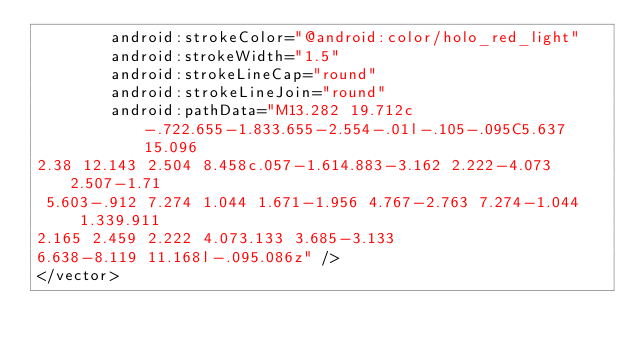Convert code to text. <code><loc_0><loc_0><loc_500><loc_500><_XML_>        android:strokeColor="@android:color/holo_red_light"
        android:strokeWidth="1.5"
        android:strokeLineCap="round"
        android:strokeLineJoin="round"
        android:pathData="M13.282 19.712c-.722.655-1.833.655-2.554-.01l-.105-.095C5.637 15.096
2.38 12.143 2.504 8.458c.057-1.614.883-3.162 2.222-4.073 2.507-1.71
 5.603-.912 7.274 1.044 1.671-1.956 4.767-2.763 7.274-1.044 1.339.911
2.165 2.459 2.222 4.073.133 3.685-3.133
6.638-8.119 11.168l-.095.086z" />
</vector></code> 